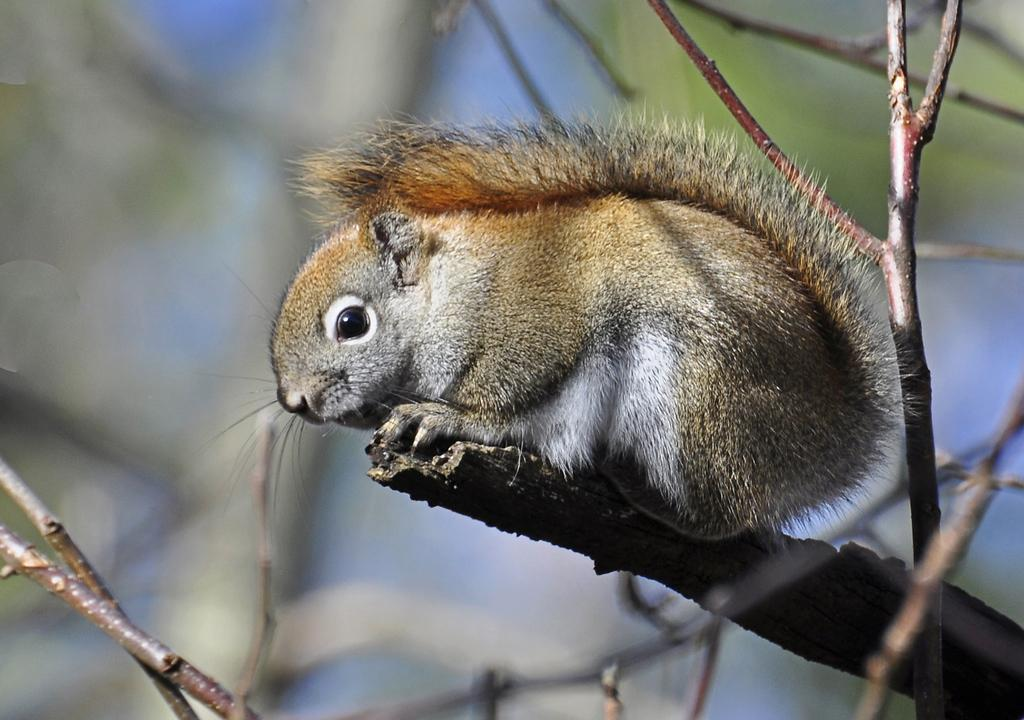What animal is present in the image? There is a squirrel in the image. Where is the squirrel located? The squirrel is on a branch. Can you describe the background of the image? The background of the image is blurred. How many children are sitting on the sofa in the image? There are no children or sofa present in the image; it features a squirrel on a branch with a blurred background. 